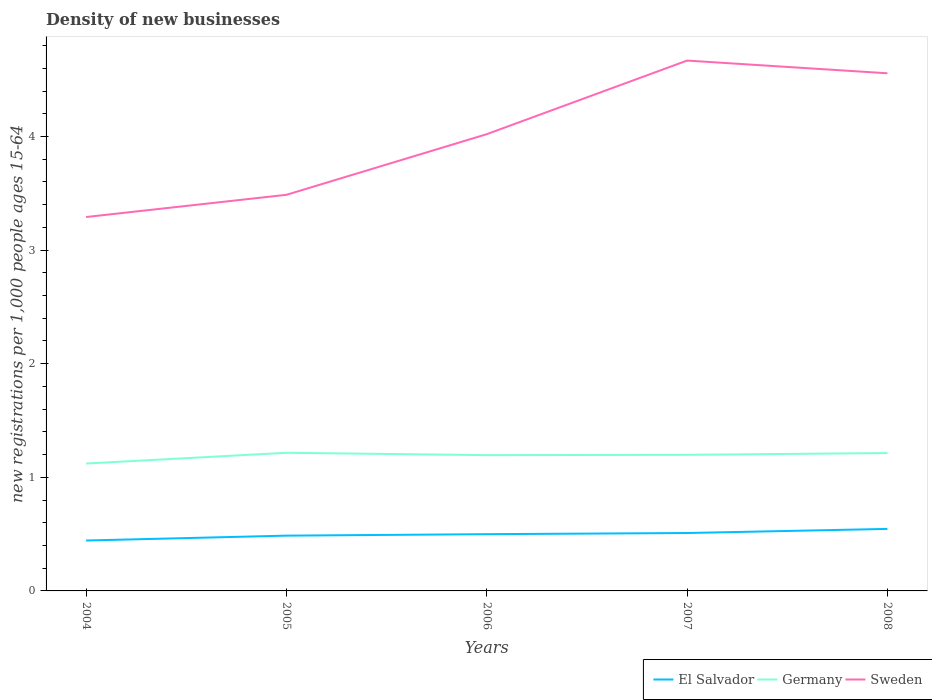How many different coloured lines are there?
Provide a succinct answer. 3. Does the line corresponding to Sweden intersect with the line corresponding to Germany?
Keep it short and to the point. No. Is the number of lines equal to the number of legend labels?
Provide a succinct answer. Yes. Across all years, what is the maximum number of new registrations in Germany?
Keep it short and to the point. 1.12. What is the total number of new registrations in Germany in the graph?
Make the answer very short. -0.08. What is the difference between the highest and the second highest number of new registrations in Germany?
Ensure brevity in your answer.  0.09. Is the number of new registrations in Germany strictly greater than the number of new registrations in Sweden over the years?
Ensure brevity in your answer.  Yes. How many lines are there?
Your response must be concise. 3. How many years are there in the graph?
Your response must be concise. 5. What is the difference between two consecutive major ticks on the Y-axis?
Your answer should be very brief. 1. Does the graph contain any zero values?
Offer a terse response. No. What is the title of the graph?
Provide a short and direct response. Density of new businesses. Does "Antigua and Barbuda" appear as one of the legend labels in the graph?
Ensure brevity in your answer.  No. What is the label or title of the Y-axis?
Offer a terse response. New registrations per 1,0 people ages 15-64. What is the new registrations per 1,000 people ages 15-64 of El Salvador in 2004?
Ensure brevity in your answer.  0.44. What is the new registrations per 1,000 people ages 15-64 in Germany in 2004?
Your response must be concise. 1.12. What is the new registrations per 1,000 people ages 15-64 of Sweden in 2004?
Offer a terse response. 3.29. What is the new registrations per 1,000 people ages 15-64 of El Salvador in 2005?
Offer a very short reply. 0.49. What is the new registrations per 1,000 people ages 15-64 in Germany in 2005?
Your answer should be very brief. 1.22. What is the new registrations per 1,000 people ages 15-64 of Sweden in 2005?
Keep it short and to the point. 3.49. What is the new registrations per 1,000 people ages 15-64 in El Salvador in 2006?
Your answer should be compact. 0.5. What is the new registrations per 1,000 people ages 15-64 of Germany in 2006?
Give a very brief answer. 1.2. What is the new registrations per 1,000 people ages 15-64 of Sweden in 2006?
Your answer should be compact. 4.02. What is the new registrations per 1,000 people ages 15-64 in El Salvador in 2007?
Provide a short and direct response. 0.51. What is the new registrations per 1,000 people ages 15-64 in Germany in 2007?
Offer a terse response. 1.2. What is the new registrations per 1,000 people ages 15-64 in Sweden in 2007?
Your answer should be very brief. 4.67. What is the new registrations per 1,000 people ages 15-64 in El Salvador in 2008?
Give a very brief answer. 0.55. What is the new registrations per 1,000 people ages 15-64 in Germany in 2008?
Offer a very short reply. 1.21. What is the new registrations per 1,000 people ages 15-64 of Sweden in 2008?
Offer a very short reply. 4.56. Across all years, what is the maximum new registrations per 1,000 people ages 15-64 in El Salvador?
Make the answer very short. 0.55. Across all years, what is the maximum new registrations per 1,000 people ages 15-64 in Germany?
Your response must be concise. 1.22. Across all years, what is the maximum new registrations per 1,000 people ages 15-64 of Sweden?
Provide a short and direct response. 4.67. Across all years, what is the minimum new registrations per 1,000 people ages 15-64 of El Salvador?
Your response must be concise. 0.44. Across all years, what is the minimum new registrations per 1,000 people ages 15-64 of Germany?
Give a very brief answer. 1.12. Across all years, what is the minimum new registrations per 1,000 people ages 15-64 of Sweden?
Make the answer very short. 3.29. What is the total new registrations per 1,000 people ages 15-64 in El Salvador in the graph?
Your response must be concise. 2.49. What is the total new registrations per 1,000 people ages 15-64 in Germany in the graph?
Ensure brevity in your answer.  5.94. What is the total new registrations per 1,000 people ages 15-64 in Sweden in the graph?
Provide a succinct answer. 20.02. What is the difference between the new registrations per 1,000 people ages 15-64 in El Salvador in 2004 and that in 2005?
Offer a terse response. -0.04. What is the difference between the new registrations per 1,000 people ages 15-64 in Germany in 2004 and that in 2005?
Your response must be concise. -0.09. What is the difference between the new registrations per 1,000 people ages 15-64 in Sweden in 2004 and that in 2005?
Your answer should be very brief. -0.2. What is the difference between the new registrations per 1,000 people ages 15-64 in El Salvador in 2004 and that in 2006?
Provide a short and direct response. -0.06. What is the difference between the new registrations per 1,000 people ages 15-64 of Germany in 2004 and that in 2006?
Offer a very short reply. -0.07. What is the difference between the new registrations per 1,000 people ages 15-64 of Sweden in 2004 and that in 2006?
Give a very brief answer. -0.73. What is the difference between the new registrations per 1,000 people ages 15-64 of El Salvador in 2004 and that in 2007?
Your answer should be compact. -0.07. What is the difference between the new registrations per 1,000 people ages 15-64 of Germany in 2004 and that in 2007?
Offer a very short reply. -0.08. What is the difference between the new registrations per 1,000 people ages 15-64 of Sweden in 2004 and that in 2007?
Your answer should be compact. -1.38. What is the difference between the new registrations per 1,000 people ages 15-64 of El Salvador in 2004 and that in 2008?
Provide a succinct answer. -0.1. What is the difference between the new registrations per 1,000 people ages 15-64 in Germany in 2004 and that in 2008?
Provide a short and direct response. -0.09. What is the difference between the new registrations per 1,000 people ages 15-64 in Sweden in 2004 and that in 2008?
Offer a terse response. -1.27. What is the difference between the new registrations per 1,000 people ages 15-64 in El Salvador in 2005 and that in 2006?
Provide a succinct answer. -0.01. What is the difference between the new registrations per 1,000 people ages 15-64 in Germany in 2005 and that in 2006?
Your answer should be very brief. 0.02. What is the difference between the new registrations per 1,000 people ages 15-64 in Sweden in 2005 and that in 2006?
Provide a short and direct response. -0.53. What is the difference between the new registrations per 1,000 people ages 15-64 of El Salvador in 2005 and that in 2007?
Your answer should be very brief. -0.02. What is the difference between the new registrations per 1,000 people ages 15-64 in Germany in 2005 and that in 2007?
Your answer should be very brief. 0.02. What is the difference between the new registrations per 1,000 people ages 15-64 of Sweden in 2005 and that in 2007?
Your answer should be compact. -1.18. What is the difference between the new registrations per 1,000 people ages 15-64 of El Salvador in 2005 and that in 2008?
Provide a succinct answer. -0.06. What is the difference between the new registrations per 1,000 people ages 15-64 in Germany in 2005 and that in 2008?
Offer a terse response. 0. What is the difference between the new registrations per 1,000 people ages 15-64 of Sweden in 2005 and that in 2008?
Your answer should be compact. -1.07. What is the difference between the new registrations per 1,000 people ages 15-64 of El Salvador in 2006 and that in 2007?
Ensure brevity in your answer.  -0.01. What is the difference between the new registrations per 1,000 people ages 15-64 in Germany in 2006 and that in 2007?
Your answer should be very brief. -0. What is the difference between the new registrations per 1,000 people ages 15-64 of Sweden in 2006 and that in 2007?
Ensure brevity in your answer.  -0.65. What is the difference between the new registrations per 1,000 people ages 15-64 in El Salvador in 2006 and that in 2008?
Your answer should be very brief. -0.05. What is the difference between the new registrations per 1,000 people ages 15-64 in Germany in 2006 and that in 2008?
Offer a terse response. -0.02. What is the difference between the new registrations per 1,000 people ages 15-64 in Sweden in 2006 and that in 2008?
Offer a very short reply. -0.54. What is the difference between the new registrations per 1,000 people ages 15-64 of El Salvador in 2007 and that in 2008?
Provide a short and direct response. -0.04. What is the difference between the new registrations per 1,000 people ages 15-64 in Germany in 2007 and that in 2008?
Provide a short and direct response. -0.02. What is the difference between the new registrations per 1,000 people ages 15-64 in Sweden in 2007 and that in 2008?
Ensure brevity in your answer.  0.11. What is the difference between the new registrations per 1,000 people ages 15-64 in El Salvador in 2004 and the new registrations per 1,000 people ages 15-64 in Germany in 2005?
Provide a short and direct response. -0.77. What is the difference between the new registrations per 1,000 people ages 15-64 of El Salvador in 2004 and the new registrations per 1,000 people ages 15-64 of Sweden in 2005?
Your response must be concise. -3.04. What is the difference between the new registrations per 1,000 people ages 15-64 of Germany in 2004 and the new registrations per 1,000 people ages 15-64 of Sweden in 2005?
Ensure brevity in your answer.  -2.37. What is the difference between the new registrations per 1,000 people ages 15-64 in El Salvador in 2004 and the new registrations per 1,000 people ages 15-64 in Germany in 2006?
Your answer should be very brief. -0.75. What is the difference between the new registrations per 1,000 people ages 15-64 in El Salvador in 2004 and the new registrations per 1,000 people ages 15-64 in Sweden in 2006?
Provide a succinct answer. -3.58. What is the difference between the new registrations per 1,000 people ages 15-64 of Germany in 2004 and the new registrations per 1,000 people ages 15-64 of Sweden in 2006?
Your answer should be very brief. -2.9. What is the difference between the new registrations per 1,000 people ages 15-64 in El Salvador in 2004 and the new registrations per 1,000 people ages 15-64 in Germany in 2007?
Your answer should be very brief. -0.75. What is the difference between the new registrations per 1,000 people ages 15-64 of El Salvador in 2004 and the new registrations per 1,000 people ages 15-64 of Sweden in 2007?
Your answer should be very brief. -4.22. What is the difference between the new registrations per 1,000 people ages 15-64 of Germany in 2004 and the new registrations per 1,000 people ages 15-64 of Sweden in 2007?
Make the answer very short. -3.55. What is the difference between the new registrations per 1,000 people ages 15-64 of El Salvador in 2004 and the new registrations per 1,000 people ages 15-64 of Germany in 2008?
Your response must be concise. -0.77. What is the difference between the new registrations per 1,000 people ages 15-64 of El Salvador in 2004 and the new registrations per 1,000 people ages 15-64 of Sweden in 2008?
Offer a very short reply. -4.11. What is the difference between the new registrations per 1,000 people ages 15-64 in Germany in 2004 and the new registrations per 1,000 people ages 15-64 in Sweden in 2008?
Provide a short and direct response. -3.43. What is the difference between the new registrations per 1,000 people ages 15-64 in El Salvador in 2005 and the new registrations per 1,000 people ages 15-64 in Germany in 2006?
Offer a very short reply. -0.71. What is the difference between the new registrations per 1,000 people ages 15-64 of El Salvador in 2005 and the new registrations per 1,000 people ages 15-64 of Sweden in 2006?
Provide a short and direct response. -3.53. What is the difference between the new registrations per 1,000 people ages 15-64 in Germany in 2005 and the new registrations per 1,000 people ages 15-64 in Sweden in 2006?
Offer a very short reply. -2.8. What is the difference between the new registrations per 1,000 people ages 15-64 of El Salvador in 2005 and the new registrations per 1,000 people ages 15-64 of Germany in 2007?
Make the answer very short. -0.71. What is the difference between the new registrations per 1,000 people ages 15-64 in El Salvador in 2005 and the new registrations per 1,000 people ages 15-64 in Sweden in 2007?
Provide a short and direct response. -4.18. What is the difference between the new registrations per 1,000 people ages 15-64 of Germany in 2005 and the new registrations per 1,000 people ages 15-64 of Sweden in 2007?
Your answer should be very brief. -3.45. What is the difference between the new registrations per 1,000 people ages 15-64 of El Salvador in 2005 and the new registrations per 1,000 people ages 15-64 of Germany in 2008?
Offer a terse response. -0.73. What is the difference between the new registrations per 1,000 people ages 15-64 in El Salvador in 2005 and the new registrations per 1,000 people ages 15-64 in Sweden in 2008?
Your answer should be very brief. -4.07. What is the difference between the new registrations per 1,000 people ages 15-64 in Germany in 2005 and the new registrations per 1,000 people ages 15-64 in Sweden in 2008?
Keep it short and to the point. -3.34. What is the difference between the new registrations per 1,000 people ages 15-64 in El Salvador in 2006 and the new registrations per 1,000 people ages 15-64 in Germany in 2007?
Provide a succinct answer. -0.7. What is the difference between the new registrations per 1,000 people ages 15-64 of El Salvador in 2006 and the new registrations per 1,000 people ages 15-64 of Sweden in 2007?
Keep it short and to the point. -4.17. What is the difference between the new registrations per 1,000 people ages 15-64 in Germany in 2006 and the new registrations per 1,000 people ages 15-64 in Sweden in 2007?
Keep it short and to the point. -3.47. What is the difference between the new registrations per 1,000 people ages 15-64 in El Salvador in 2006 and the new registrations per 1,000 people ages 15-64 in Germany in 2008?
Ensure brevity in your answer.  -0.71. What is the difference between the new registrations per 1,000 people ages 15-64 in El Salvador in 2006 and the new registrations per 1,000 people ages 15-64 in Sweden in 2008?
Your answer should be compact. -4.06. What is the difference between the new registrations per 1,000 people ages 15-64 in Germany in 2006 and the new registrations per 1,000 people ages 15-64 in Sweden in 2008?
Make the answer very short. -3.36. What is the difference between the new registrations per 1,000 people ages 15-64 of El Salvador in 2007 and the new registrations per 1,000 people ages 15-64 of Germany in 2008?
Keep it short and to the point. -0.7. What is the difference between the new registrations per 1,000 people ages 15-64 of El Salvador in 2007 and the new registrations per 1,000 people ages 15-64 of Sweden in 2008?
Provide a succinct answer. -4.05. What is the difference between the new registrations per 1,000 people ages 15-64 in Germany in 2007 and the new registrations per 1,000 people ages 15-64 in Sweden in 2008?
Provide a succinct answer. -3.36. What is the average new registrations per 1,000 people ages 15-64 of El Salvador per year?
Your answer should be compact. 0.5. What is the average new registrations per 1,000 people ages 15-64 of Germany per year?
Make the answer very short. 1.19. What is the average new registrations per 1,000 people ages 15-64 of Sweden per year?
Your answer should be compact. 4. In the year 2004, what is the difference between the new registrations per 1,000 people ages 15-64 in El Salvador and new registrations per 1,000 people ages 15-64 in Germany?
Provide a short and direct response. -0.68. In the year 2004, what is the difference between the new registrations per 1,000 people ages 15-64 in El Salvador and new registrations per 1,000 people ages 15-64 in Sweden?
Your answer should be compact. -2.85. In the year 2004, what is the difference between the new registrations per 1,000 people ages 15-64 in Germany and new registrations per 1,000 people ages 15-64 in Sweden?
Give a very brief answer. -2.17. In the year 2005, what is the difference between the new registrations per 1,000 people ages 15-64 of El Salvador and new registrations per 1,000 people ages 15-64 of Germany?
Give a very brief answer. -0.73. In the year 2005, what is the difference between the new registrations per 1,000 people ages 15-64 of El Salvador and new registrations per 1,000 people ages 15-64 of Sweden?
Offer a very short reply. -3. In the year 2005, what is the difference between the new registrations per 1,000 people ages 15-64 of Germany and new registrations per 1,000 people ages 15-64 of Sweden?
Provide a succinct answer. -2.27. In the year 2006, what is the difference between the new registrations per 1,000 people ages 15-64 in El Salvador and new registrations per 1,000 people ages 15-64 in Germany?
Offer a very short reply. -0.7. In the year 2006, what is the difference between the new registrations per 1,000 people ages 15-64 in El Salvador and new registrations per 1,000 people ages 15-64 in Sweden?
Your answer should be compact. -3.52. In the year 2006, what is the difference between the new registrations per 1,000 people ages 15-64 in Germany and new registrations per 1,000 people ages 15-64 in Sweden?
Provide a succinct answer. -2.83. In the year 2007, what is the difference between the new registrations per 1,000 people ages 15-64 of El Salvador and new registrations per 1,000 people ages 15-64 of Germany?
Your answer should be compact. -0.69. In the year 2007, what is the difference between the new registrations per 1,000 people ages 15-64 in El Salvador and new registrations per 1,000 people ages 15-64 in Sweden?
Ensure brevity in your answer.  -4.16. In the year 2007, what is the difference between the new registrations per 1,000 people ages 15-64 in Germany and new registrations per 1,000 people ages 15-64 in Sweden?
Keep it short and to the point. -3.47. In the year 2008, what is the difference between the new registrations per 1,000 people ages 15-64 of El Salvador and new registrations per 1,000 people ages 15-64 of Germany?
Offer a very short reply. -0.67. In the year 2008, what is the difference between the new registrations per 1,000 people ages 15-64 in El Salvador and new registrations per 1,000 people ages 15-64 in Sweden?
Provide a succinct answer. -4.01. In the year 2008, what is the difference between the new registrations per 1,000 people ages 15-64 of Germany and new registrations per 1,000 people ages 15-64 of Sweden?
Your response must be concise. -3.34. What is the ratio of the new registrations per 1,000 people ages 15-64 in El Salvador in 2004 to that in 2005?
Your response must be concise. 0.91. What is the ratio of the new registrations per 1,000 people ages 15-64 in Germany in 2004 to that in 2005?
Your response must be concise. 0.92. What is the ratio of the new registrations per 1,000 people ages 15-64 in Sweden in 2004 to that in 2005?
Ensure brevity in your answer.  0.94. What is the ratio of the new registrations per 1,000 people ages 15-64 in El Salvador in 2004 to that in 2006?
Make the answer very short. 0.89. What is the ratio of the new registrations per 1,000 people ages 15-64 of Germany in 2004 to that in 2006?
Your answer should be compact. 0.94. What is the ratio of the new registrations per 1,000 people ages 15-64 of Sweden in 2004 to that in 2006?
Your answer should be very brief. 0.82. What is the ratio of the new registrations per 1,000 people ages 15-64 of El Salvador in 2004 to that in 2007?
Provide a succinct answer. 0.87. What is the ratio of the new registrations per 1,000 people ages 15-64 in Germany in 2004 to that in 2007?
Provide a short and direct response. 0.94. What is the ratio of the new registrations per 1,000 people ages 15-64 in Sweden in 2004 to that in 2007?
Provide a short and direct response. 0.7. What is the ratio of the new registrations per 1,000 people ages 15-64 in El Salvador in 2004 to that in 2008?
Your answer should be very brief. 0.81. What is the ratio of the new registrations per 1,000 people ages 15-64 of Germany in 2004 to that in 2008?
Provide a short and direct response. 0.92. What is the ratio of the new registrations per 1,000 people ages 15-64 in Sweden in 2004 to that in 2008?
Your answer should be very brief. 0.72. What is the ratio of the new registrations per 1,000 people ages 15-64 of El Salvador in 2005 to that in 2006?
Ensure brevity in your answer.  0.97. What is the ratio of the new registrations per 1,000 people ages 15-64 in Germany in 2005 to that in 2006?
Make the answer very short. 1.02. What is the ratio of the new registrations per 1,000 people ages 15-64 of Sweden in 2005 to that in 2006?
Make the answer very short. 0.87. What is the ratio of the new registrations per 1,000 people ages 15-64 in El Salvador in 2005 to that in 2007?
Your answer should be very brief. 0.95. What is the ratio of the new registrations per 1,000 people ages 15-64 in Sweden in 2005 to that in 2007?
Offer a terse response. 0.75. What is the ratio of the new registrations per 1,000 people ages 15-64 in El Salvador in 2005 to that in 2008?
Offer a very short reply. 0.89. What is the ratio of the new registrations per 1,000 people ages 15-64 in Sweden in 2005 to that in 2008?
Your answer should be compact. 0.77. What is the ratio of the new registrations per 1,000 people ages 15-64 in El Salvador in 2006 to that in 2007?
Offer a terse response. 0.98. What is the ratio of the new registrations per 1,000 people ages 15-64 in Germany in 2006 to that in 2007?
Your response must be concise. 1. What is the ratio of the new registrations per 1,000 people ages 15-64 of Sweden in 2006 to that in 2007?
Offer a very short reply. 0.86. What is the ratio of the new registrations per 1,000 people ages 15-64 in El Salvador in 2006 to that in 2008?
Offer a very short reply. 0.92. What is the ratio of the new registrations per 1,000 people ages 15-64 of Sweden in 2006 to that in 2008?
Offer a terse response. 0.88. What is the ratio of the new registrations per 1,000 people ages 15-64 of El Salvador in 2007 to that in 2008?
Give a very brief answer. 0.93. What is the ratio of the new registrations per 1,000 people ages 15-64 of Germany in 2007 to that in 2008?
Offer a very short reply. 0.99. What is the ratio of the new registrations per 1,000 people ages 15-64 in Sweden in 2007 to that in 2008?
Your answer should be very brief. 1.02. What is the difference between the highest and the second highest new registrations per 1,000 people ages 15-64 in El Salvador?
Keep it short and to the point. 0.04. What is the difference between the highest and the second highest new registrations per 1,000 people ages 15-64 in Germany?
Your response must be concise. 0. What is the difference between the highest and the second highest new registrations per 1,000 people ages 15-64 in Sweden?
Your answer should be compact. 0.11. What is the difference between the highest and the lowest new registrations per 1,000 people ages 15-64 in El Salvador?
Give a very brief answer. 0.1. What is the difference between the highest and the lowest new registrations per 1,000 people ages 15-64 in Germany?
Keep it short and to the point. 0.09. What is the difference between the highest and the lowest new registrations per 1,000 people ages 15-64 of Sweden?
Your answer should be very brief. 1.38. 